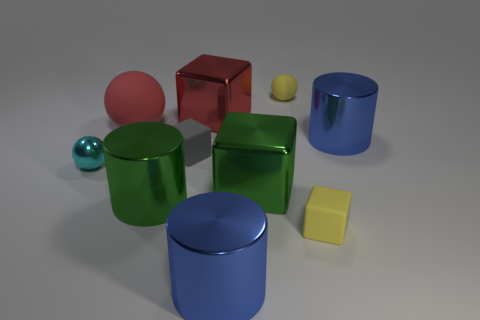What material is the big block that is in front of the shiny thing on the right side of the yellow thing behind the large green cylinder made of?
Your response must be concise. Metal. What number of metal objects are big red things or small yellow cubes?
Provide a short and direct response. 1. Is there a gray ball?
Give a very brief answer. No. What color is the tiny rubber object that is behind the matte sphere in front of the red metal thing?
Keep it short and to the point. Yellow. What number of other things are there of the same color as the small metallic thing?
Provide a short and direct response. 0. How many things are big blue objects or blocks that are behind the large red matte ball?
Make the answer very short. 3. There is a matte object that is behind the red block; what color is it?
Give a very brief answer. Yellow. What is the shape of the tiny cyan object?
Give a very brief answer. Sphere. What is the material of the large sphere behind the small yellow matte thing in front of the red shiny object?
Offer a terse response. Rubber. How many other objects are there of the same material as the tiny gray object?
Offer a very short reply. 3. 